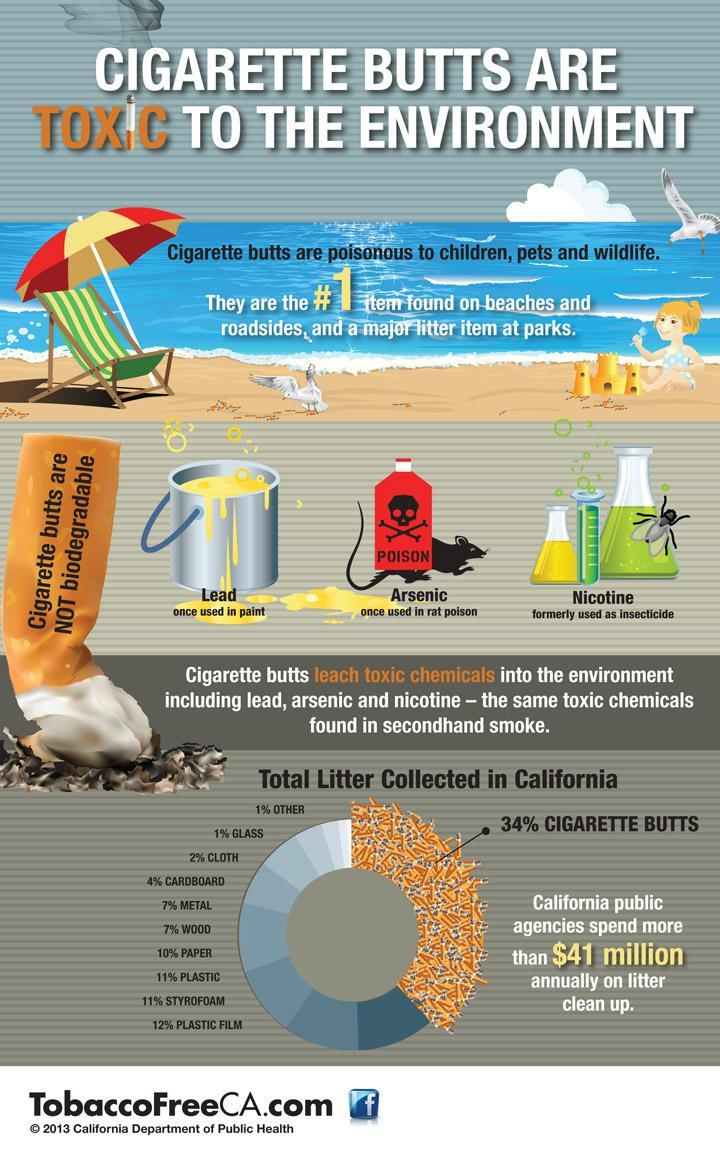Are cigarette butts biodegradable or non-biodegradable?
Answer the question with a short phrase. non-biodegradable What percent of litter is paper , plastic film and plastic that is collected in California? 33% 